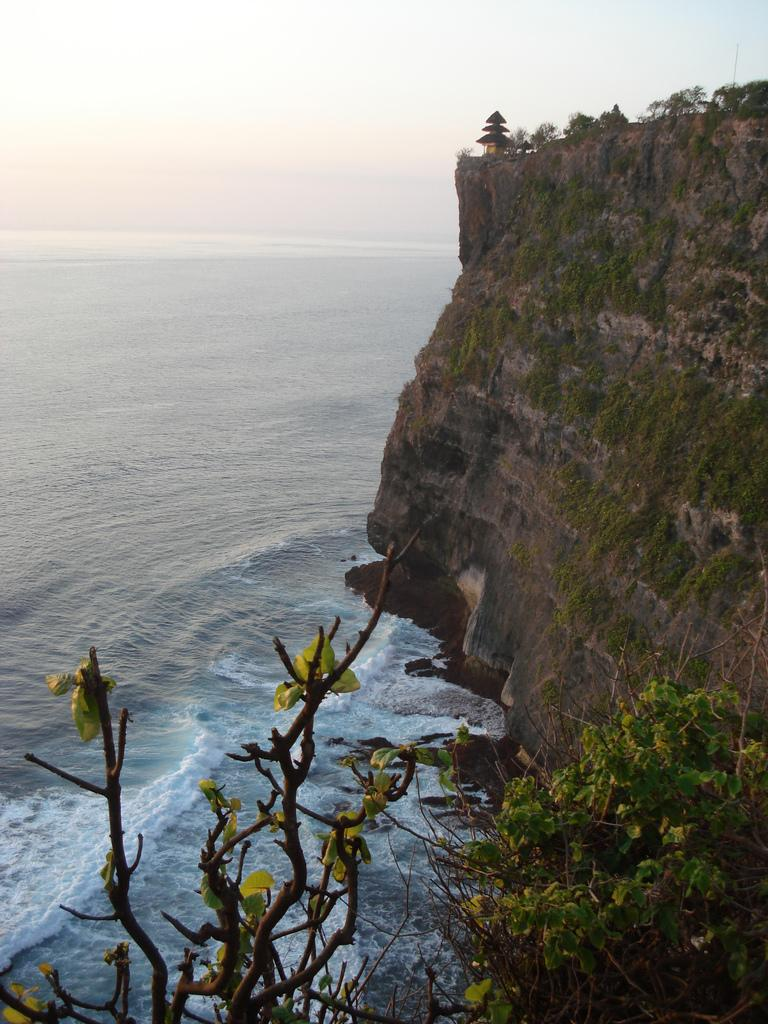What type of landform is present in the image? There is a hill in the image. What type of vegetation can be seen in the image? There are plants and trees visible in the image. Where are the trees located in the image? The trees are at the bottom of the image. What can be seen besides the land and vegetation in the image? Water is visible in the image. What is visible at the top of the image? The sky is visible at the top of the image. What type of grape is growing on the hill in the image? There are no grapes present in the image; it features a hill, plants, trees, water, and the sky. How many cherries can be seen on the trees in the image? There are no cherries present in the image; it features a hill, plants, trees, water, and the sky. 